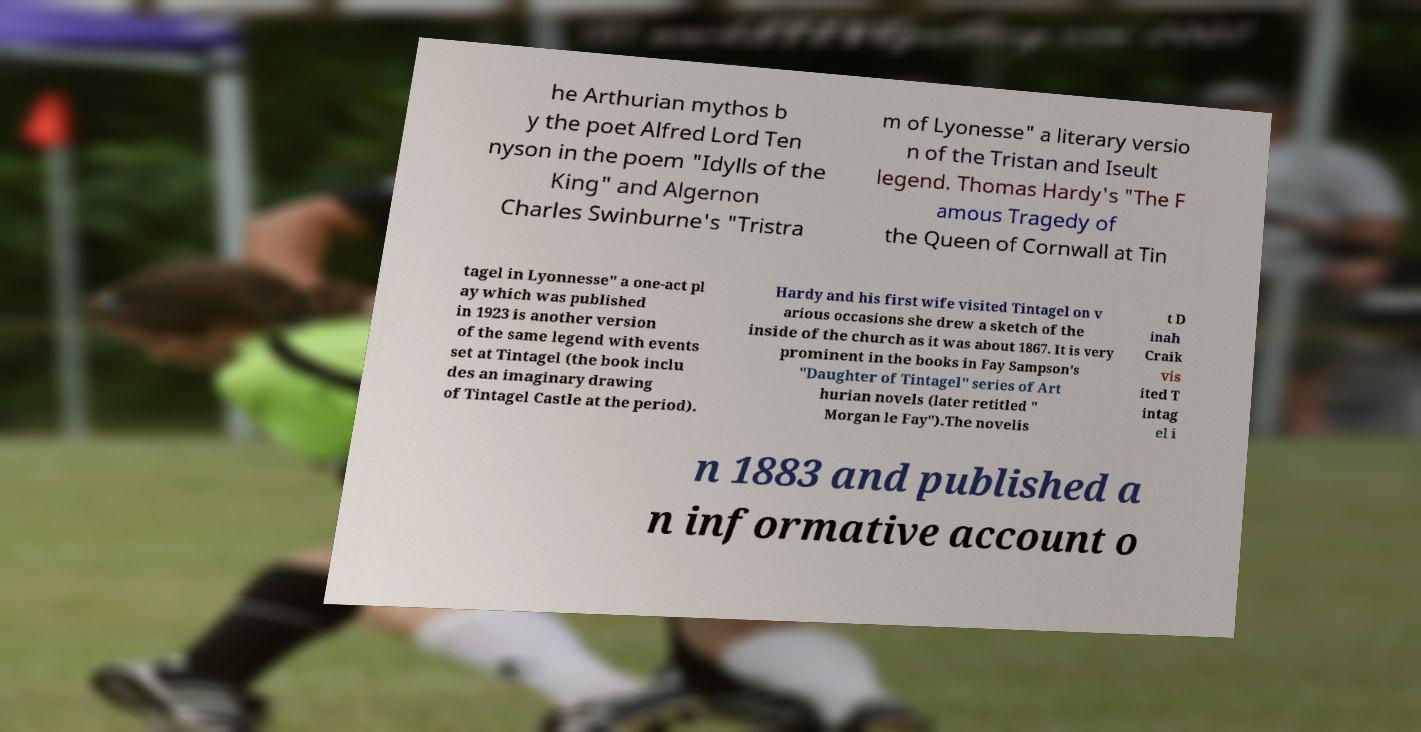Could you assist in decoding the text presented in this image and type it out clearly? he Arthurian mythos b y the poet Alfred Lord Ten nyson in the poem "Idylls of the King" and Algernon Charles Swinburne's "Tristra m of Lyonesse" a literary versio n of the Tristan and Iseult legend. Thomas Hardy's "The F amous Tragedy of the Queen of Cornwall at Tin tagel in Lyonnesse" a one-act pl ay which was published in 1923 is another version of the same legend with events set at Tintagel (the book inclu des an imaginary drawing of Tintagel Castle at the period). Hardy and his first wife visited Tintagel on v arious occasions she drew a sketch of the inside of the church as it was about 1867. It is very prominent in the books in Fay Sampson's "Daughter of Tintagel" series of Art hurian novels (later retitled " Morgan le Fay").The novelis t D inah Craik vis ited T intag el i n 1883 and published a n informative account o 